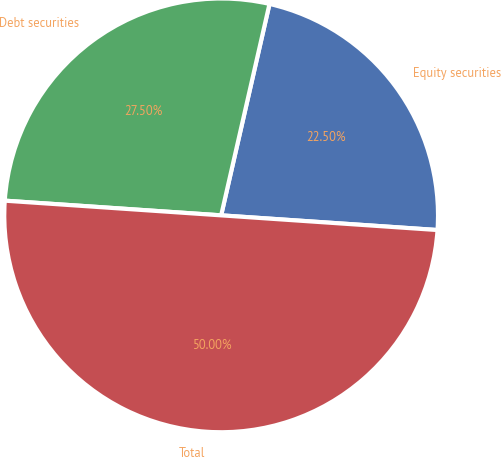Convert chart. <chart><loc_0><loc_0><loc_500><loc_500><pie_chart><fcel>Equity securities<fcel>Debt securities<fcel>Total<nl><fcel>22.5%<fcel>27.5%<fcel>50.0%<nl></chart> 